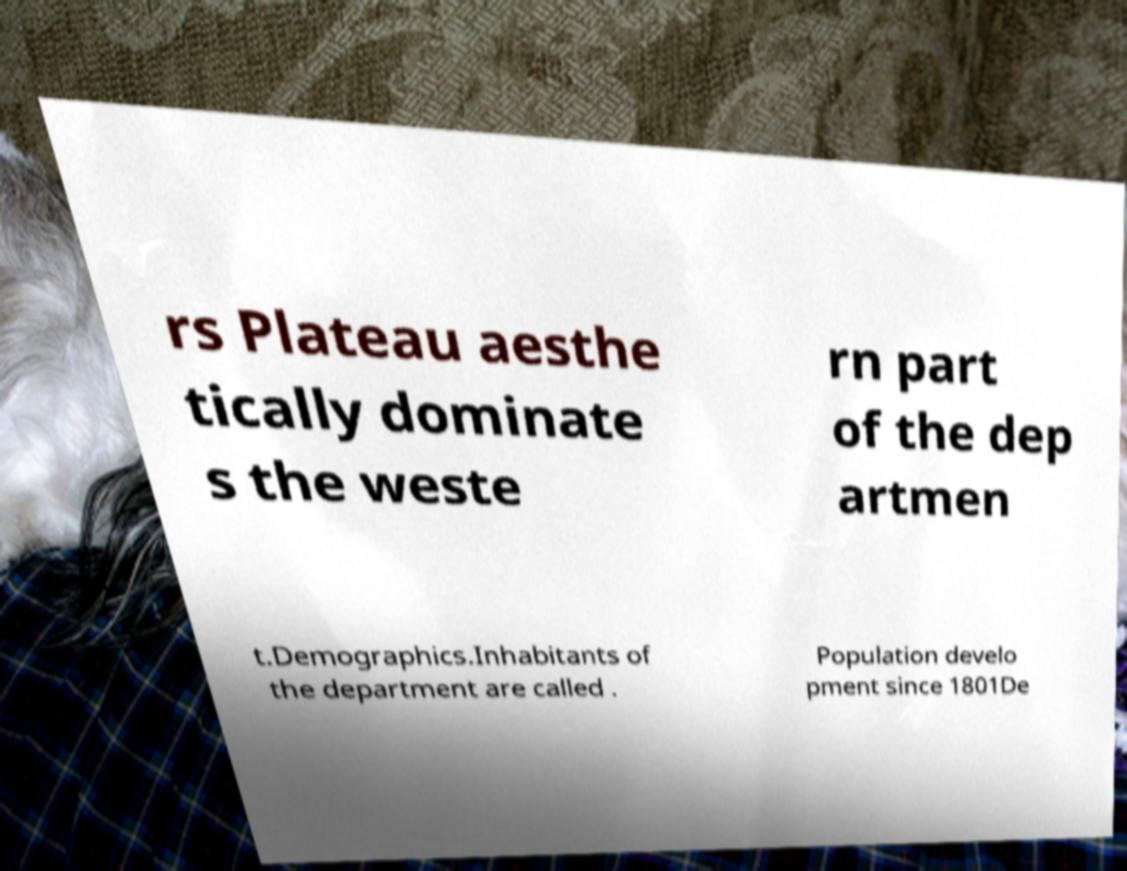Can you read and provide the text displayed in the image?This photo seems to have some interesting text. Can you extract and type it out for me? rs Plateau aesthe tically dominate s the weste rn part of the dep artmen t.Demographics.Inhabitants of the department are called . Population develo pment since 1801De 